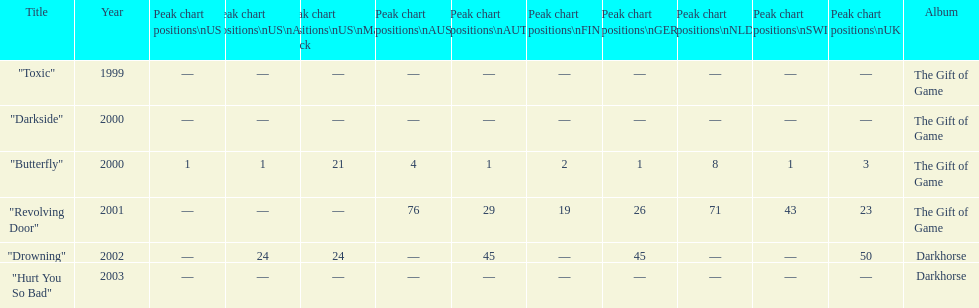On how many occasions did the single "butterfly" attain a rank of 1 on the chart? 5. 